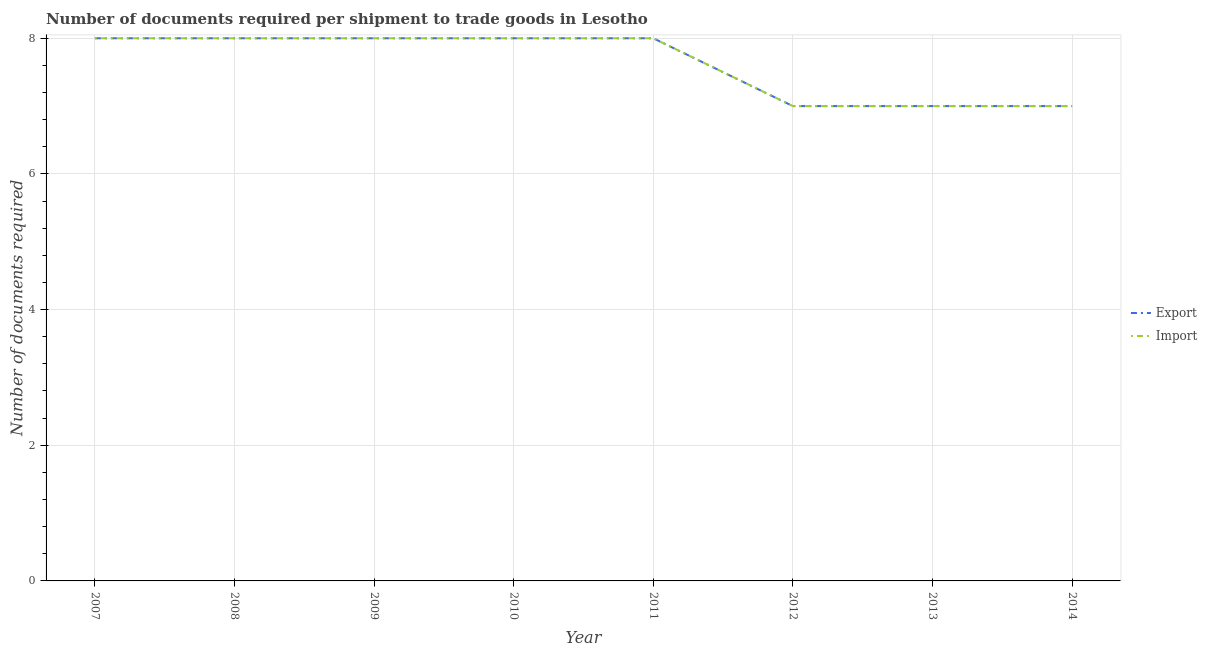Does the line corresponding to number of documents required to import goods intersect with the line corresponding to number of documents required to export goods?
Provide a succinct answer. Yes. Is the number of lines equal to the number of legend labels?
Offer a very short reply. Yes. What is the number of documents required to export goods in 2012?
Offer a very short reply. 7. Across all years, what is the maximum number of documents required to import goods?
Keep it short and to the point. 8. Across all years, what is the minimum number of documents required to export goods?
Make the answer very short. 7. In which year was the number of documents required to import goods maximum?
Provide a succinct answer. 2007. In which year was the number of documents required to export goods minimum?
Offer a very short reply. 2012. What is the total number of documents required to export goods in the graph?
Keep it short and to the point. 61. What is the difference between the number of documents required to export goods in 2010 and that in 2014?
Your answer should be compact. 1. What is the average number of documents required to export goods per year?
Provide a succinct answer. 7.62. In how many years, is the number of documents required to import goods greater than 4.8?
Your answer should be very brief. 8. Is the number of documents required to export goods in 2007 less than that in 2008?
Provide a short and direct response. No. What is the difference between the highest and the lowest number of documents required to export goods?
Your answer should be very brief. 1. Is the sum of the number of documents required to export goods in 2009 and 2013 greater than the maximum number of documents required to import goods across all years?
Your answer should be very brief. Yes. Does the number of documents required to import goods monotonically increase over the years?
Offer a very short reply. No. Is the number of documents required to import goods strictly less than the number of documents required to export goods over the years?
Give a very brief answer. No. How many years are there in the graph?
Your answer should be very brief. 8. What is the difference between two consecutive major ticks on the Y-axis?
Your answer should be compact. 2. What is the title of the graph?
Keep it short and to the point. Number of documents required per shipment to trade goods in Lesotho. Does "Resident" appear as one of the legend labels in the graph?
Keep it short and to the point. No. What is the label or title of the X-axis?
Provide a short and direct response. Year. What is the label or title of the Y-axis?
Give a very brief answer. Number of documents required. What is the Number of documents required in Import in 2007?
Provide a succinct answer. 8. What is the Number of documents required of Export in 2010?
Make the answer very short. 8. What is the Number of documents required of Import in 2011?
Ensure brevity in your answer.  8. What is the Number of documents required of Import in 2012?
Your answer should be very brief. 7. What is the Number of documents required of Export in 2013?
Provide a succinct answer. 7. What is the Number of documents required in Import in 2013?
Offer a very short reply. 7. What is the Number of documents required of Export in 2014?
Your answer should be compact. 7. Across all years, what is the maximum Number of documents required of Import?
Offer a terse response. 8. Across all years, what is the minimum Number of documents required in Export?
Your answer should be very brief. 7. What is the difference between the Number of documents required in Export in 2007 and that in 2009?
Provide a succinct answer. 0. What is the difference between the Number of documents required in Import in 2007 and that in 2009?
Give a very brief answer. 0. What is the difference between the Number of documents required of Export in 2007 and that in 2010?
Ensure brevity in your answer.  0. What is the difference between the Number of documents required of Import in 2007 and that in 2013?
Your answer should be compact. 1. What is the difference between the Number of documents required in Import in 2007 and that in 2014?
Your answer should be compact. 1. What is the difference between the Number of documents required in Export in 2008 and that in 2009?
Make the answer very short. 0. What is the difference between the Number of documents required of Export in 2008 and that in 2010?
Your answer should be compact. 0. What is the difference between the Number of documents required in Import in 2008 and that in 2010?
Make the answer very short. 0. What is the difference between the Number of documents required in Import in 2008 and that in 2011?
Make the answer very short. 0. What is the difference between the Number of documents required of Import in 2008 and that in 2012?
Provide a short and direct response. 1. What is the difference between the Number of documents required of Export in 2008 and that in 2014?
Ensure brevity in your answer.  1. What is the difference between the Number of documents required in Import in 2009 and that in 2010?
Your answer should be very brief. 0. What is the difference between the Number of documents required in Import in 2009 and that in 2011?
Your answer should be compact. 0. What is the difference between the Number of documents required of Export in 2009 and that in 2012?
Your answer should be very brief. 1. What is the difference between the Number of documents required in Export in 2009 and that in 2013?
Give a very brief answer. 1. What is the difference between the Number of documents required in Export in 2010 and that in 2013?
Offer a very short reply. 1. What is the difference between the Number of documents required of Import in 2010 and that in 2013?
Keep it short and to the point. 1. What is the difference between the Number of documents required of Export in 2010 and that in 2014?
Give a very brief answer. 1. What is the difference between the Number of documents required of Export in 2011 and that in 2012?
Offer a very short reply. 1. What is the difference between the Number of documents required in Import in 2011 and that in 2013?
Ensure brevity in your answer.  1. What is the difference between the Number of documents required of Import in 2011 and that in 2014?
Your answer should be compact. 1. What is the difference between the Number of documents required in Export in 2012 and that in 2013?
Your answer should be very brief. 0. What is the difference between the Number of documents required in Import in 2012 and that in 2013?
Your response must be concise. 0. What is the difference between the Number of documents required of Export in 2012 and that in 2014?
Offer a terse response. 0. What is the difference between the Number of documents required in Import in 2012 and that in 2014?
Provide a succinct answer. 0. What is the difference between the Number of documents required of Export in 2013 and that in 2014?
Offer a terse response. 0. What is the difference between the Number of documents required of Import in 2013 and that in 2014?
Offer a very short reply. 0. What is the difference between the Number of documents required in Export in 2007 and the Number of documents required in Import in 2008?
Your answer should be compact. 0. What is the difference between the Number of documents required in Export in 2007 and the Number of documents required in Import in 2009?
Offer a very short reply. 0. What is the difference between the Number of documents required in Export in 2007 and the Number of documents required in Import in 2013?
Your answer should be very brief. 1. What is the difference between the Number of documents required of Export in 2007 and the Number of documents required of Import in 2014?
Make the answer very short. 1. What is the difference between the Number of documents required of Export in 2008 and the Number of documents required of Import in 2011?
Your answer should be compact. 0. What is the difference between the Number of documents required of Export in 2008 and the Number of documents required of Import in 2013?
Ensure brevity in your answer.  1. What is the difference between the Number of documents required in Export in 2008 and the Number of documents required in Import in 2014?
Your answer should be compact. 1. What is the difference between the Number of documents required in Export in 2009 and the Number of documents required in Import in 2011?
Offer a terse response. 0. What is the difference between the Number of documents required of Export in 2009 and the Number of documents required of Import in 2012?
Provide a succinct answer. 1. What is the difference between the Number of documents required of Export in 2009 and the Number of documents required of Import in 2014?
Ensure brevity in your answer.  1. What is the difference between the Number of documents required of Export in 2010 and the Number of documents required of Import in 2012?
Your answer should be very brief. 1. What is the difference between the Number of documents required in Export in 2011 and the Number of documents required in Import in 2012?
Give a very brief answer. 1. What is the difference between the Number of documents required of Export in 2012 and the Number of documents required of Import in 2013?
Your answer should be very brief. 0. What is the difference between the Number of documents required of Export in 2013 and the Number of documents required of Import in 2014?
Provide a short and direct response. 0. What is the average Number of documents required of Export per year?
Your answer should be very brief. 7.62. What is the average Number of documents required in Import per year?
Ensure brevity in your answer.  7.62. In the year 2007, what is the difference between the Number of documents required in Export and Number of documents required in Import?
Ensure brevity in your answer.  0. In the year 2009, what is the difference between the Number of documents required of Export and Number of documents required of Import?
Make the answer very short. 0. In the year 2014, what is the difference between the Number of documents required in Export and Number of documents required in Import?
Your response must be concise. 0. What is the ratio of the Number of documents required of Export in 2007 to that in 2008?
Your answer should be very brief. 1. What is the ratio of the Number of documents required of Import in 2007 to that in 2008?
Ensure brevity in your answer.  1. What is the ratio of the Number of documents required in Export in 2007 to that in 2009?
Provide a short and direct response. 1. What is the ratio of the Number of documents required in Import in 2007 to that in 2011?
Provide a short and direct response. 1. What is the ratio of the Number of documents required in Import in 2007 to that in 2012?
Make the answer very short. 1.14. What is the ratio of the Number of documents required of Import in 2007 to that in 2013?
Make the answer very short. 1.14. What is the ratio of the Number of documents required of Export in 2007 to that in 2014?
Make the answer very short. 1.14. What is the ratio of the Number of documents required of Import in 2007 to that in 2014?
Your answer should be compact. 1.14. What is the ratio of the Number of documents required in Export in 2008 to that in 2009?
Your response must be concise. 1. What is the ratio of the Number of documents required of Import in 2008 to that in 2009?
Your answer should be compact. 1. What is the ratio of the Number of documents required in Export in 2008 to that in 2013?
Your response must be concise. 1.14. What is the ratio of the Number of documents required in Import in 2008 to that in 2013?
Give a very brief answer. 1.14. What is the ratio of the Number of documents required in Import in 2008 to that in 2014?
Make the answer very short. 1.14. What is the ratio of the Number of documents required in Export in 2009 to that in 2012?
Your answer should be very brief. 1.14. What is the ratio of the Number of documents required of Export in 2009 to that in 2013?
Give a very brief answer. 1.14. What is the ratio of the Number of documents required in Export in 2009 to that in 2014?
Your response must be concise. 1.14. What is the ratio of the Number of documents required in Export in 2010 to that in 2012?
Your response must be concise. 1.14. What is the ratio of the Number of documents required of Import in 2010 to that in 2014?
Make the answer very short. 1.14. What is the ratio of the Number of documents required in Import in 2011 to that in 2012?
Offer a terse response. 1.14. What is the ratio of the Number of documents required in Export in 2011 to that in 2013?
Provide a short and direct response. 1.14. What is the ratio of the Number of documents required of Export in 2011 to that in 2014?
Keep it short and to the point. 1.14. What is the ratio of the Number of documents required in Export in 2012 to that in 2013?
Provide a succinct answer. 1. What is the ratio of the Number of documents required in Export in 2012 to that in 2014?
Keep it short and to the point. 1. What is the ratio of the Number of documents required in Import in 2012 to that in 2014?
Your answer should be compact. 1. What is the ratio of the Number of documents required of Import in 2013 to that in 2014?
Give a very brief answer. 1. What is the difference between the highest and the second highest Number of documents required in Export?
Your answer should be compact. 0. What is the difference between the highest and the second highest Number of documents required of Import?
Your answer should be compact. 0. What is the difference between the highest and the lowest Number of documents required of Import?
Make the answer very short. 1. 